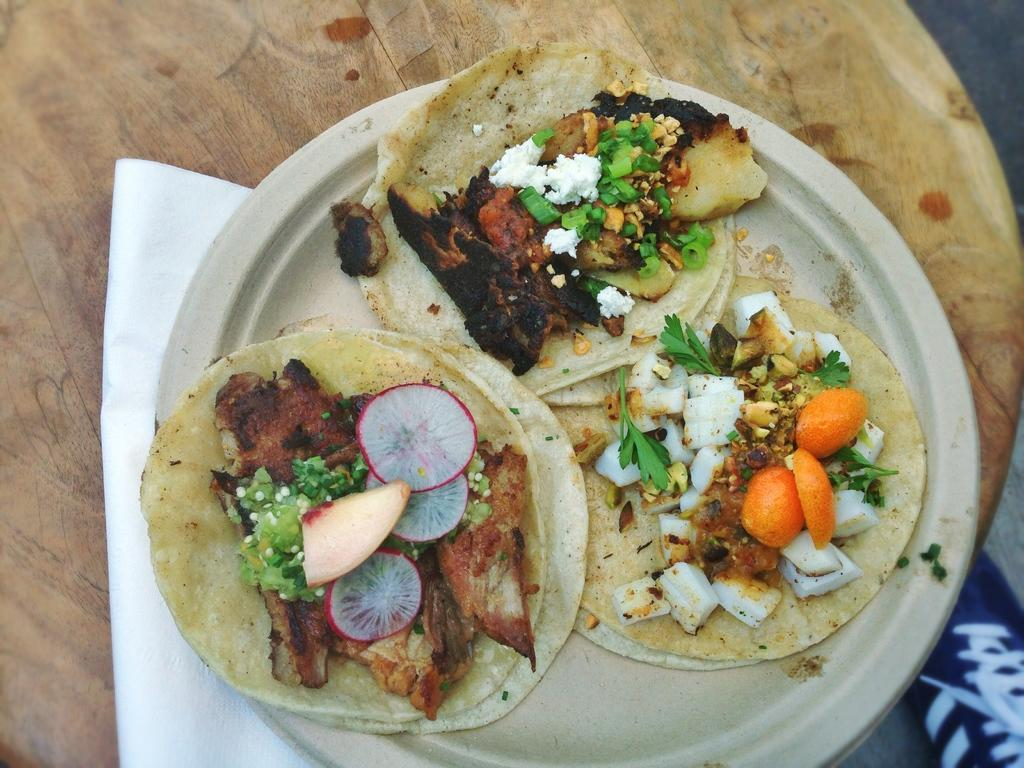What is on the plate in the image? There is food on the plate in the image. What item is located beside the plate? There is a tissue paper beside the plate. Can you tell me how many kittens are playing with the grape in the image? There are no kittens or grapes present in the image. What is the level of friction between the food and the plate in the image? The level of friction between the food and the plate cannot be determined from the image. 